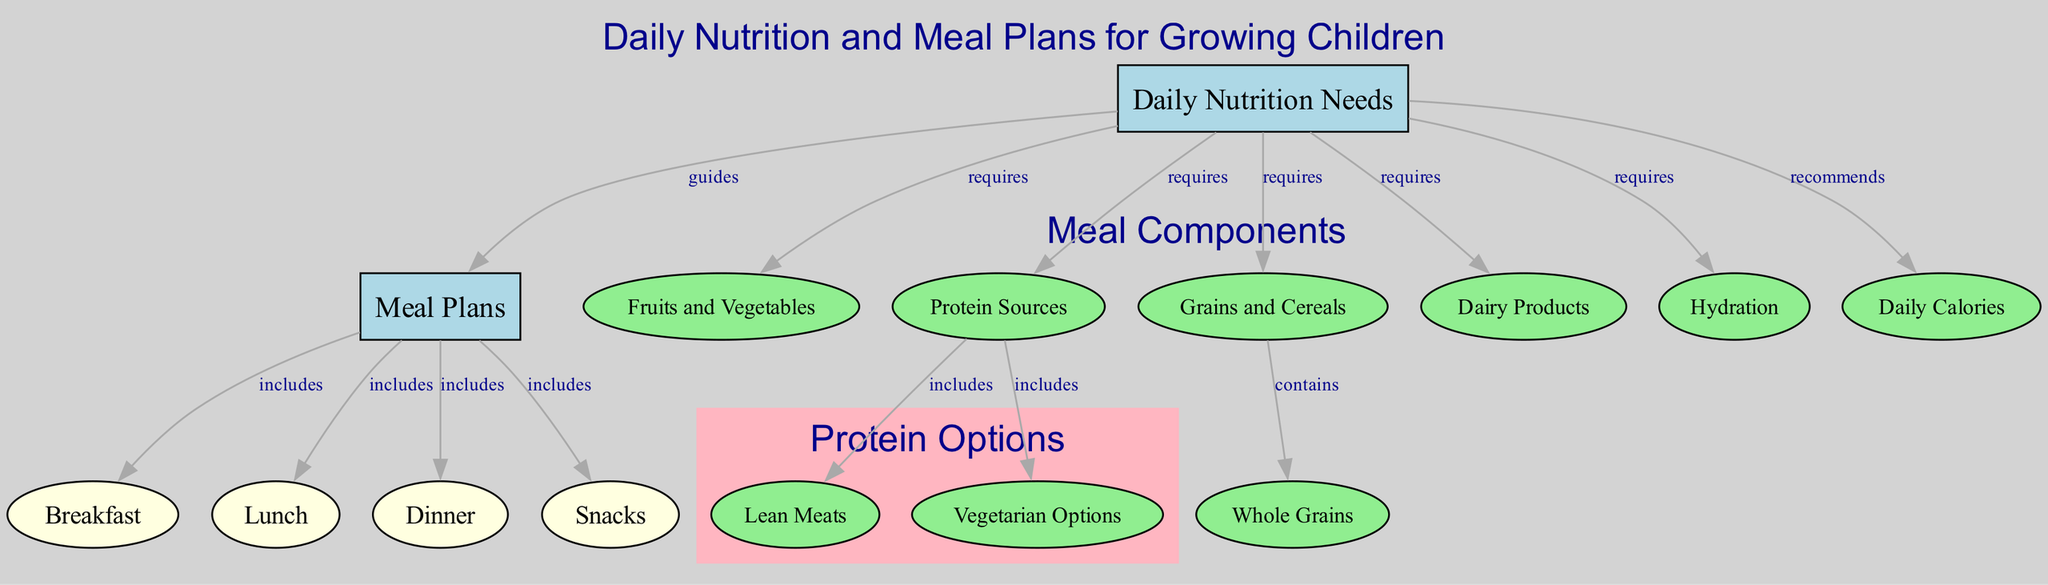What do growing children require for daily nutrition? The diagram indicates that growing children require daily nutrition needs, which is represented by the node labeled "Daily Nutrition Needs." This connects to various components such as fruits and vegetables, protein sources, grains and cereals, dairy products, and hydration.
Answer: Daily Nutrition Needs How many meal types are included in the meal plans? The diagram shows a total of four meal types included under the "Meal Plans" node: Breakfast, Lunch, Dinner, and Snacks. These meal types are distinct and connect back to Meal Plans.
Answer: Four What do we find under protein sources? The protein sources in the diagram include Lean Meats and Vegetarian Options, which are directly linked to the "Protein Sources" node. This indicates the types of protein options available.
Answer: Lean Meats and Vegetarian Options What does the "Daily Nutrition Needs" recommend? The "Daily Nutrition Needs" node indicates that it recommends a specific daily calorie intake represented by the "Daily Calories" node. This recommendation is an overarching guideline for children's nutritional goals.
Answer: Daily Calories Which category includes whole grains? The diagram links the category "Grains and Cereals" to "Whole Grains," signifying that whole grains are contained within this category. This means whole grains are an important type of grain suitable for growing children.
Answer: Grains and Cereals What color represents the "Meal Plans" in the diagram? The "Meal Plans" node is filled with a light blue color, which differentiates it from other categories in the diagram such as meal types and nutrient sources. The visual representation helps to easily identify this node.
Answer: Light blue How many edges connect to the "Meal Plans" node? The "Meal Plans" node connects with four different edges to the meal types: Breakfast, Lunch, Dinner, and Snacks. Analyzing these connections allows us to determine the total edges that illustrate the relationships of these meal types.
Answer: Four Which node is connected directly by the label 'requires'? The label 'requires' connects the "Daily Nutrition Needs" node with the nodes related to nutrition components such as fruits and vegetables, protein sources, grains, dairy, and hydration. This indicates the essential dietary components children need.
Answer: Fruits and Vegetables, Protein Sources, Grains and Cereals, Dairy Products, Hydration 